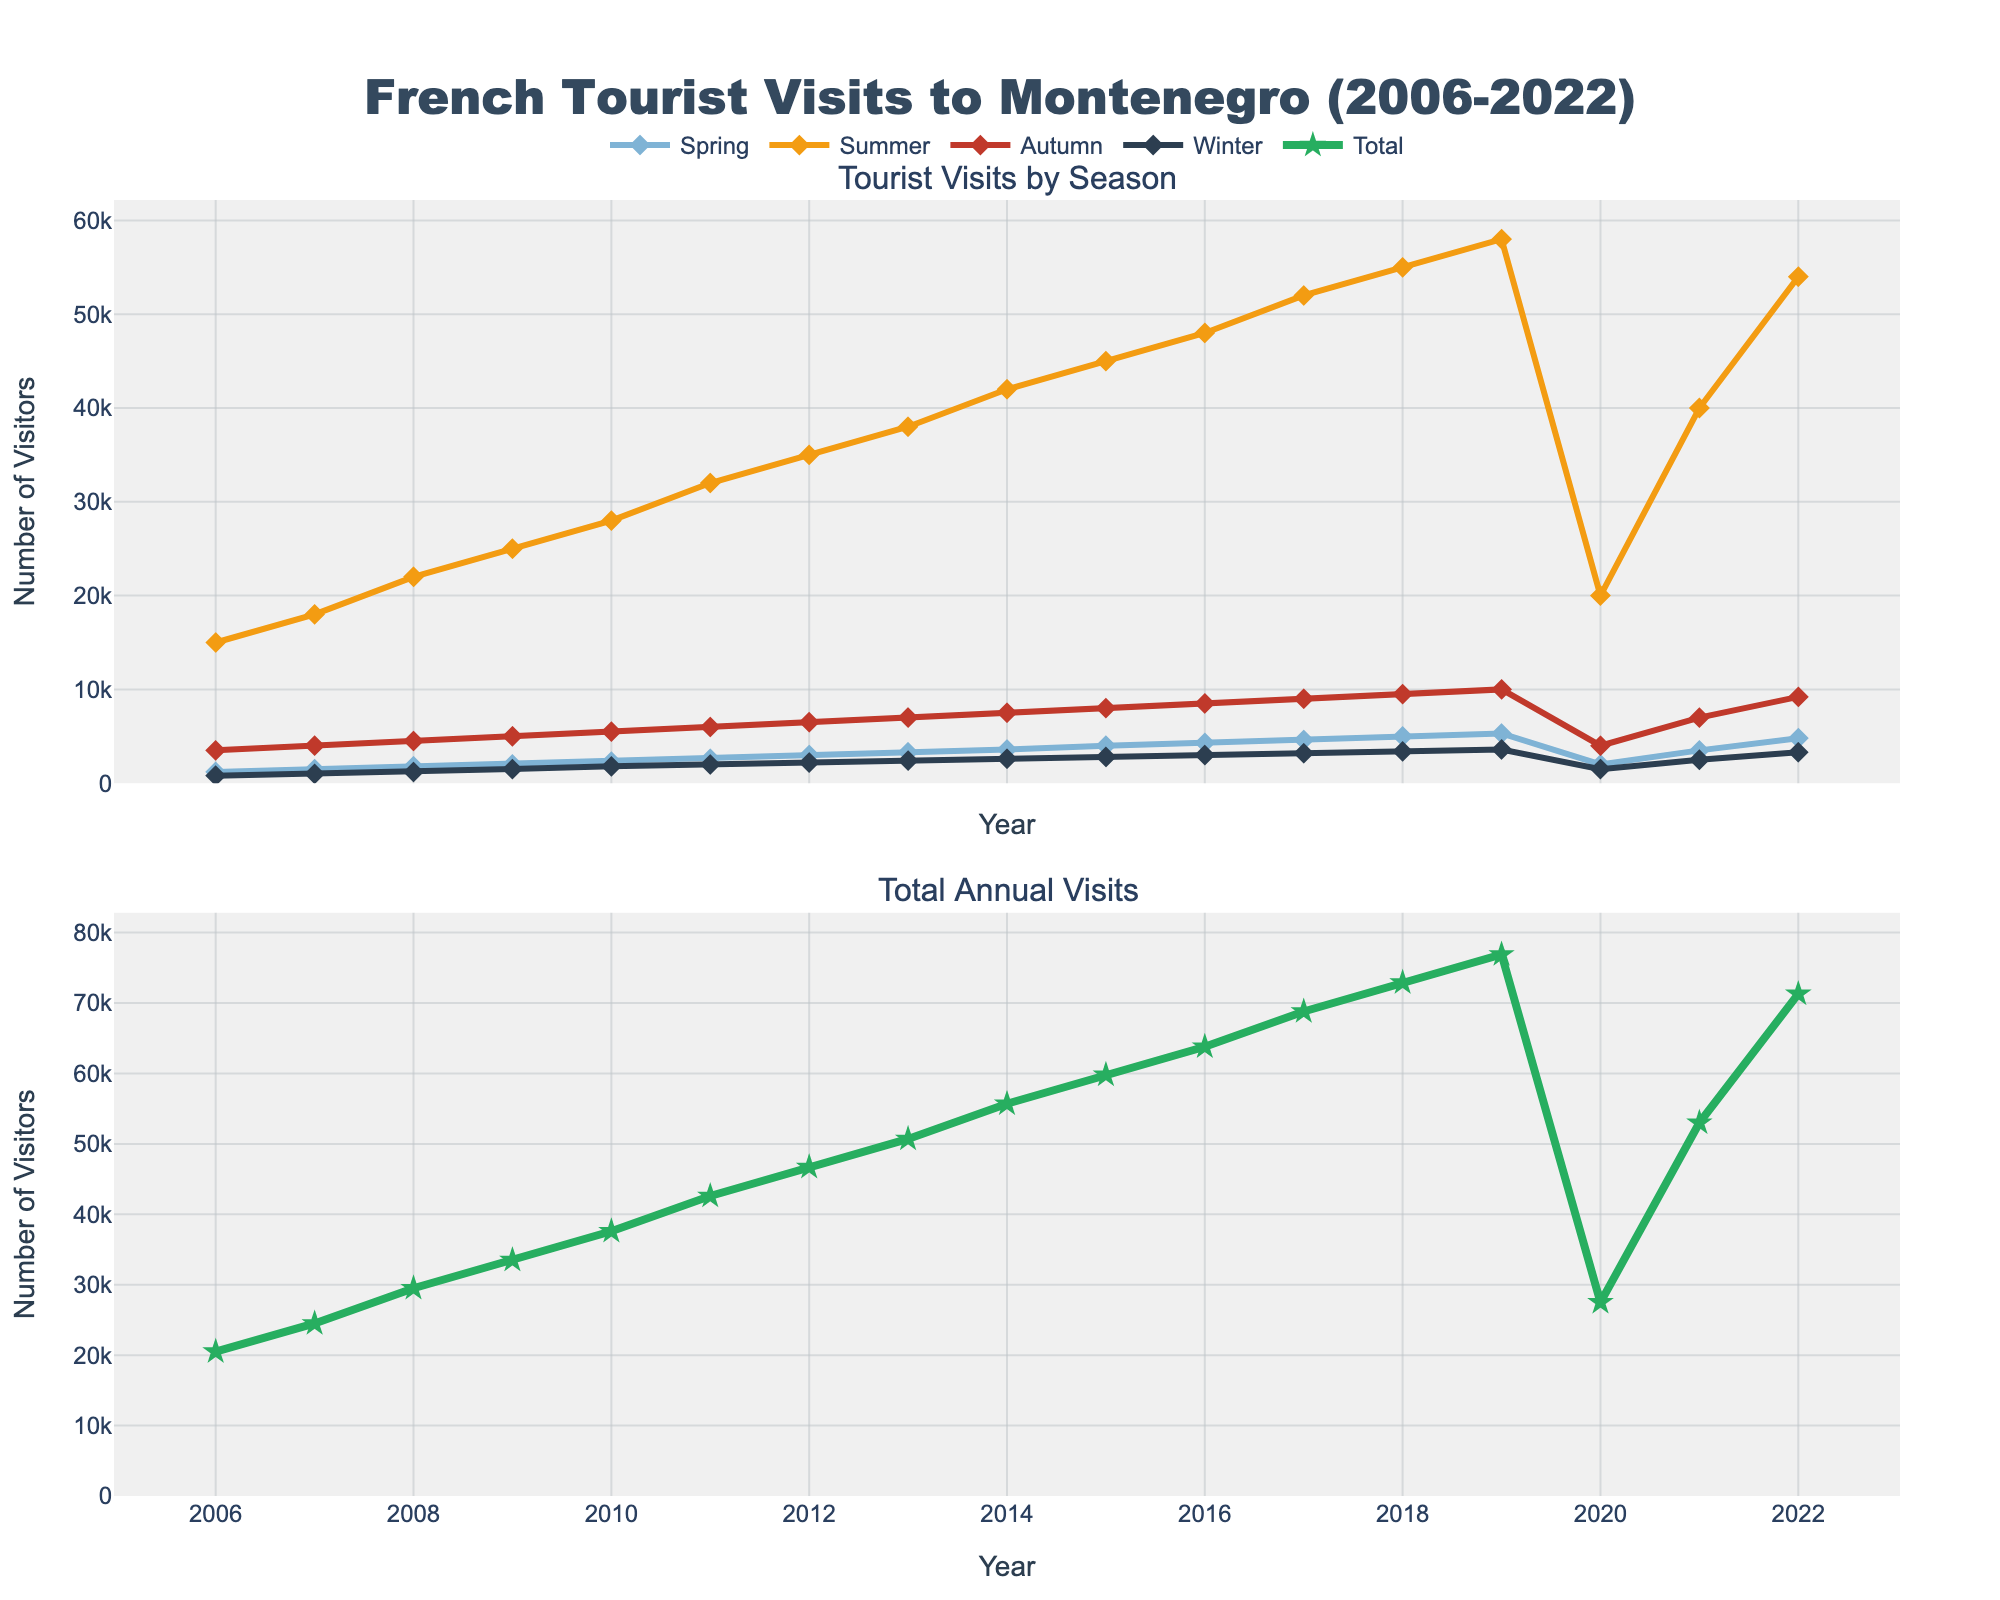What was the trend in the total number of visitors from France to Montenegro from 2006 to 2019? To determine the trend, observe the total number of visitors line plot. From 2006 to 2019, there is a consistent upward trend in the total number of visitors annually, indicating steady growth.
Answer: Consistent upward trend Which season had the highest number of visitors in 2019, and how many visitors were there? Look at the separate season lines for 2019 and identify that the Summer season has the highest point. The number of visitors in Summer is around 58,000.
Answer: Summer, 58,000 visitors Compare the number of Winter visitors in 2020 and 2021. Which year had more visitors, and by how much? Locate the Winter season points for 2020 and 2021. In 2020, there are 1,500 visitors, whereas in 2021, there are 2,500 visitors. Subtracting these gives 1,000 more visitors in 2021.
Answer: 2021, 1,000 more visitors What was the average number of Spring visitors from 2006 to 2019? To find the average, sum the Spring visitor numbers from 2006 to 2019 and divide by the number of years. Sum: 1200 + 1500 + 1800 + 2000 + 2300 + 2600 + 3000 + 3300 + 3600 + 4000 + 4300 + 4600 + 5000 + 5300 = 49,200. Average = 49,200 / 14 ≈ 3,514.
Answer: 3,514 How did the number of visitors change during the Covid-19 pandemic years (2020 and 2021) compared to 2019, for each season? Compare the number of visitors in each season for the years mentioned. Spring went from 5,300 in 2019 to 2,000 in 2020 and 3,500 in 2021. Summer went from 58,000 to 20,000 and then 40,000. Autumn went from 10,000 to 4,000 and then 7,000. Winter went from 3,600 to 1,500 and then 2,500. All seasons saw a significant drop in 2020, with partial recovery in 2021.
Answer: Significant drop in 2020 for all, partial recovery in 2021 What is the difference in the number of Autumn visitors between the peak year and the initial year? Identify the peak year for Autumn visitors which is 2019 with 10,000 visitors and the initial year (2006) with 3,500 visitors. Subtracting 3,500 from 10,000 gives a difference.
Answer: 6,500 During which year did the Summer season see the highest increase in visitors compared to the previous year? Examine the Summer season line for the largest vertical jump year-over-year. Notably, between 2007 (18,000) and 2008 (22,000), there's an increase of 4,000, which is the highest observed jump.
Answer: 2008 What's the visual difference between the total annual visits in 2020 and 2021? Observe the 'Total' line near 2020 and 2021. The line drops significantly in 2020 and rises again in 2021. The main visual difference is a downward dip followed by an upward rise.
Answer: Downward dip followed by upward rise 